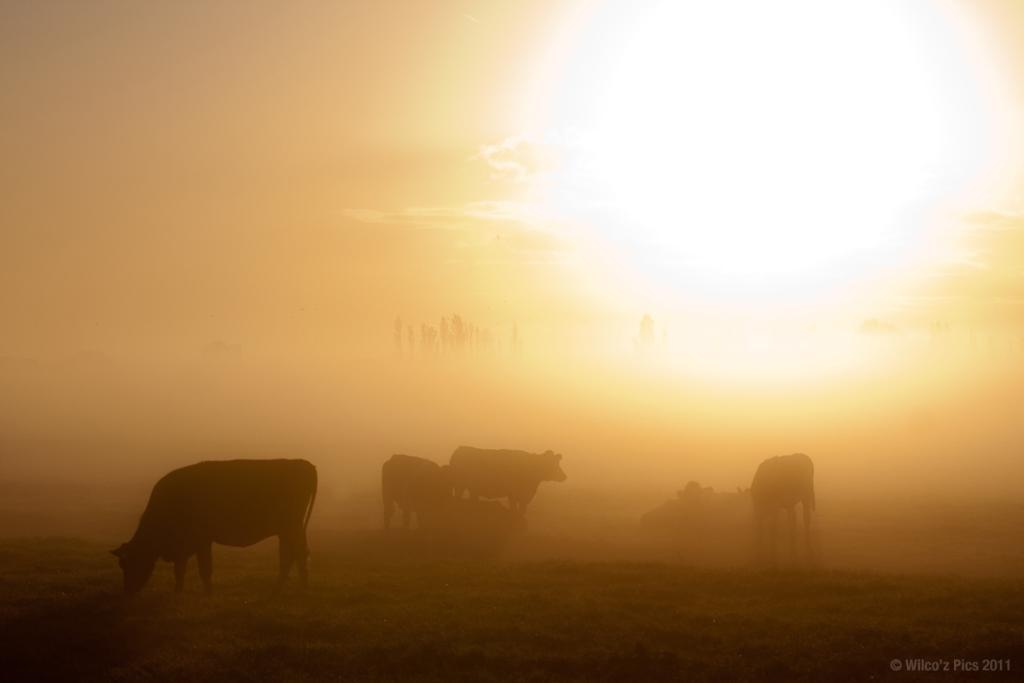What type of animals can be seen in the image? There are animals visible on the surface in the image. What celestial body is observable in the image? The sun is observable in the image. What type of can is visible in the image? There is no can present in the image. What type of fuel is being used by the animals in the image? There is no indication of any fuel being used in the image, as it features animals on a surface with the sun visible. What type of turkey can be seen in the image? There is no turkey present in the image. 